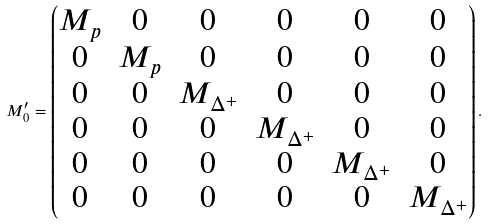<formula> <loc_0><loc_0><loc_500><loc_500>M ^ { \prime } _ { 0 } = \begin{pmatrix} M _ { p } & 0 & 0 & 0 & 0 & 0 \\ 0 & M _ { p } & 0 & 0 & 0 & 0 \\ 0 & 0 & M _ { \Delta ^ { + } } & 0 & 0 & 0 \\ 0 & 0 & 0 & M _ { \Delta ^ { + } } & 0 & 0 \\ 0 & 0 & 0 & 0 & M _ { \Delta ^ { + } } & 0 \\ 0 & 0 & 0 & 0 & 0 & M _ { \Delta ^ { + } } \end{pmatrix} .</formula> 